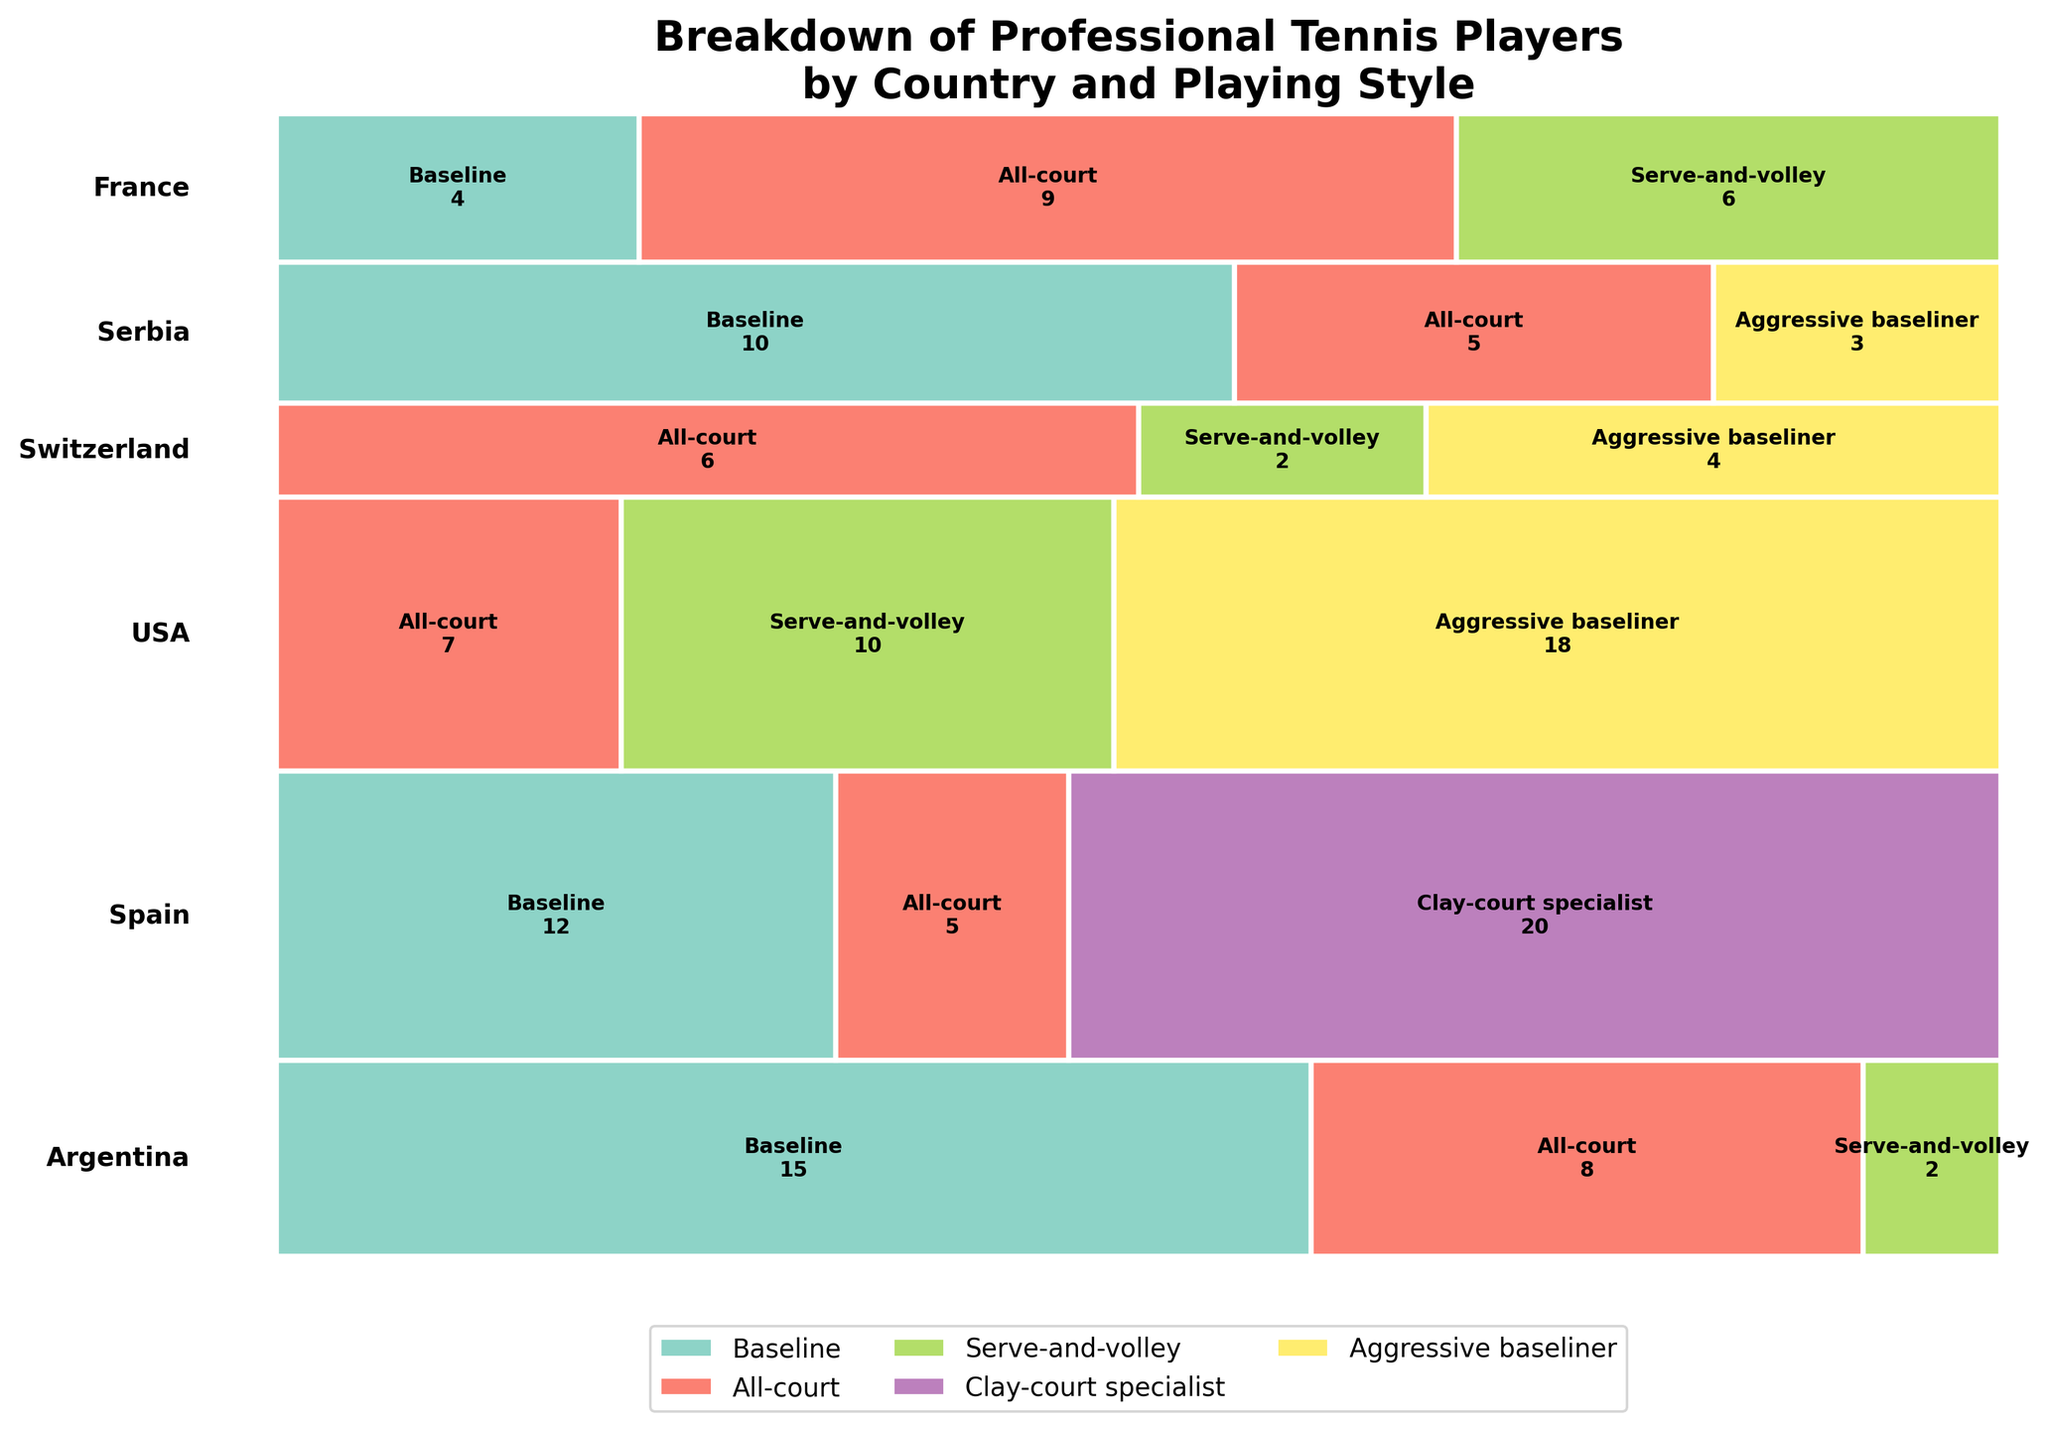What is the title of the figure? The title of the figure is the text displayed at the top of the plot, summarizing the content.
Answer: Breakdown of Professional Tennis Players by Country and Playing Style Which country has the most tennis players represented in the plot? The country with the largest overall height in the mosaic plot has the most tennis players represented.
Answer: Spain What playing styles are present for players from Argentina? To determine the playing styles for Argentina, look at the types of styles listed within the segment representing Argentina.
Answer: Baseline, All-court, Serve-and-volley How many Serve-and-volley players are there in total? Sum up the number of Serve-and-volley players from each country as indicated in their segments.
Answer: 20 In which country is Baseline the most common playing style? Identify the country where the largest proportion of the segment is labeled Baseline, relative to the others within that country.
Answer: Argentina What percentage of USA players use the Aggressive baseliner style? Determine the width of the Aggressive baseliner segment within the USA and divide by the total width for USA.
Answer: 18/35 (approximately 51.4%) Is the All-court playing style more common in France or Switzerland? Compare the width of the All-court segments in France and Switzerland.
Answer: France Which countries have players using more than two distinct playing styles? Check for countries that have three different segments (different colors), indicating three distinct playing styles.
Answer: Argentina, USA, Switzerland, Serbia, France How does the number of All-court players in Spain compare to the number in France? Look at the segments labeled All-court in Spain and France and compare the numbers indicated.
Answer: Spain has fewer All-court players (5) than France (9) What is the total number of players represented in the plot? Sum up the counts of players from all countries and playing styles.
Answer: 140 